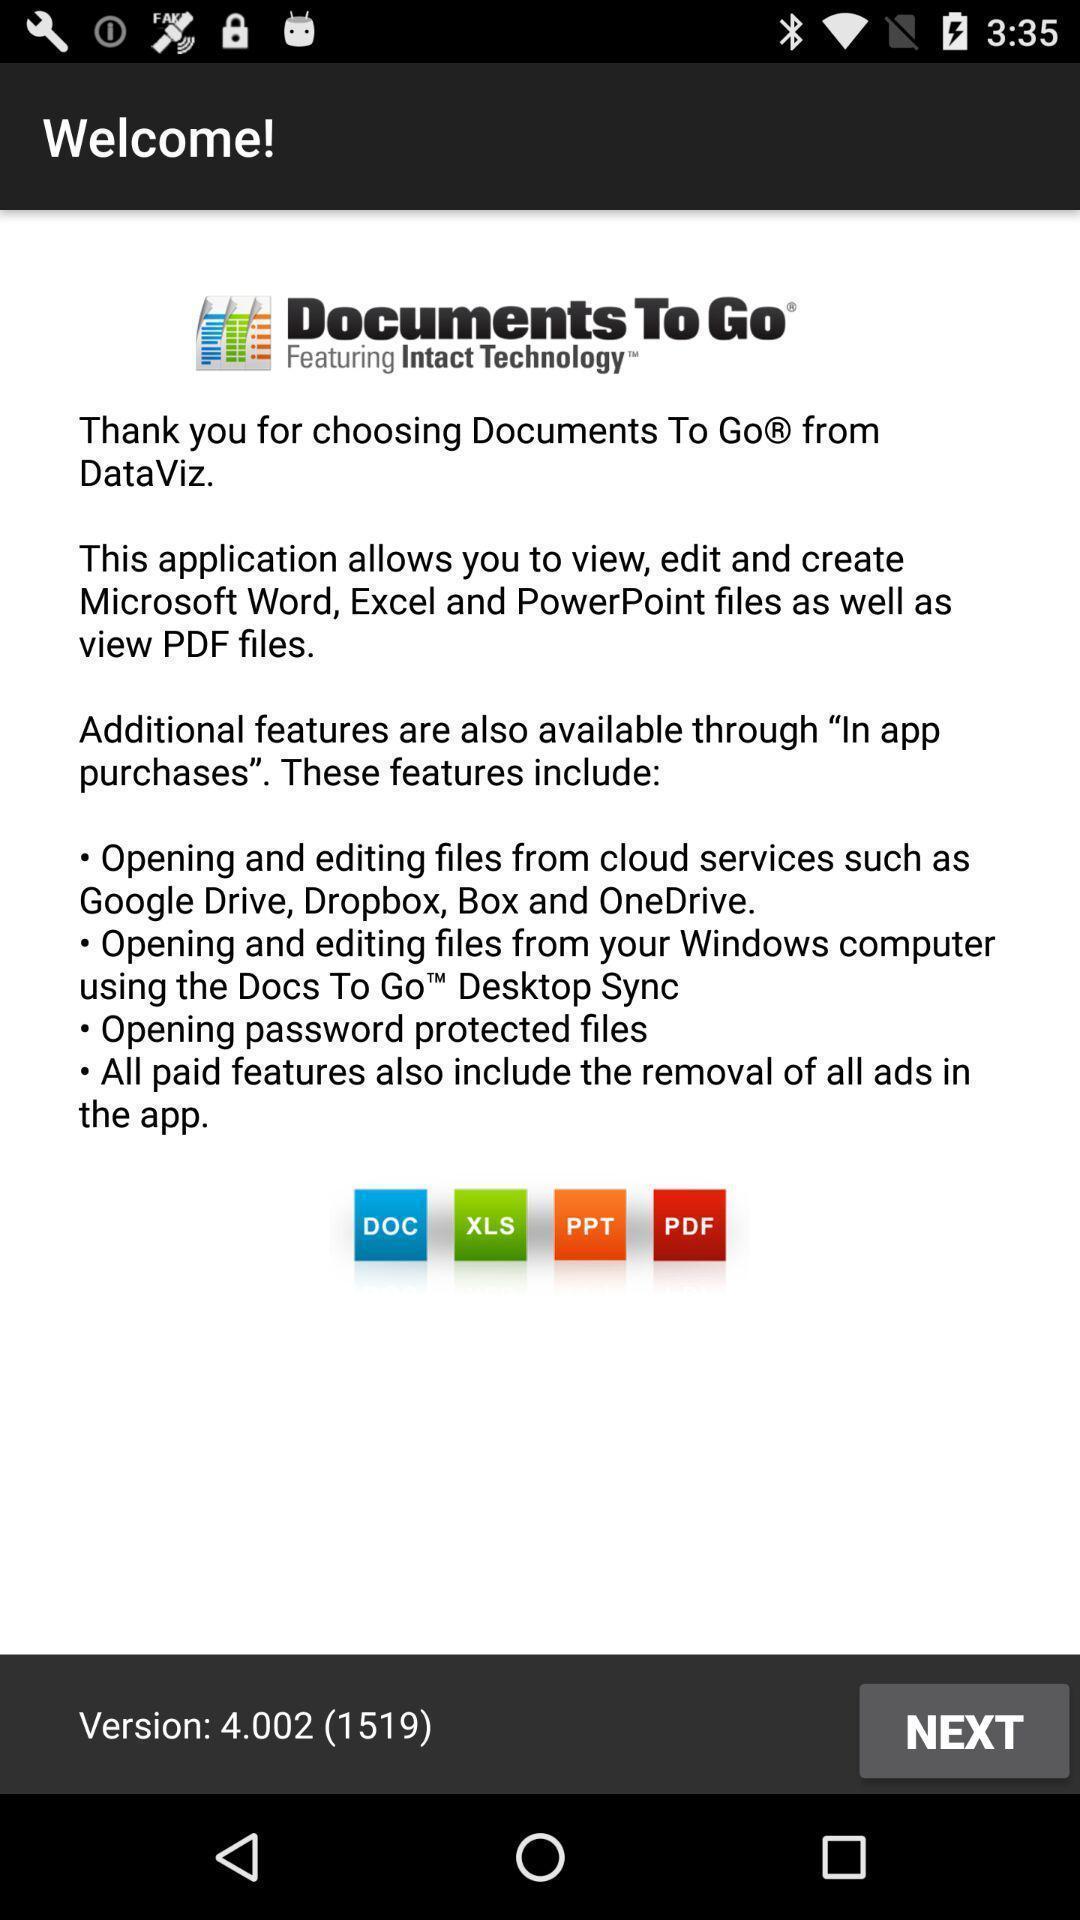Give me a summary of this screen capture. Welcome page of a data editing app. 